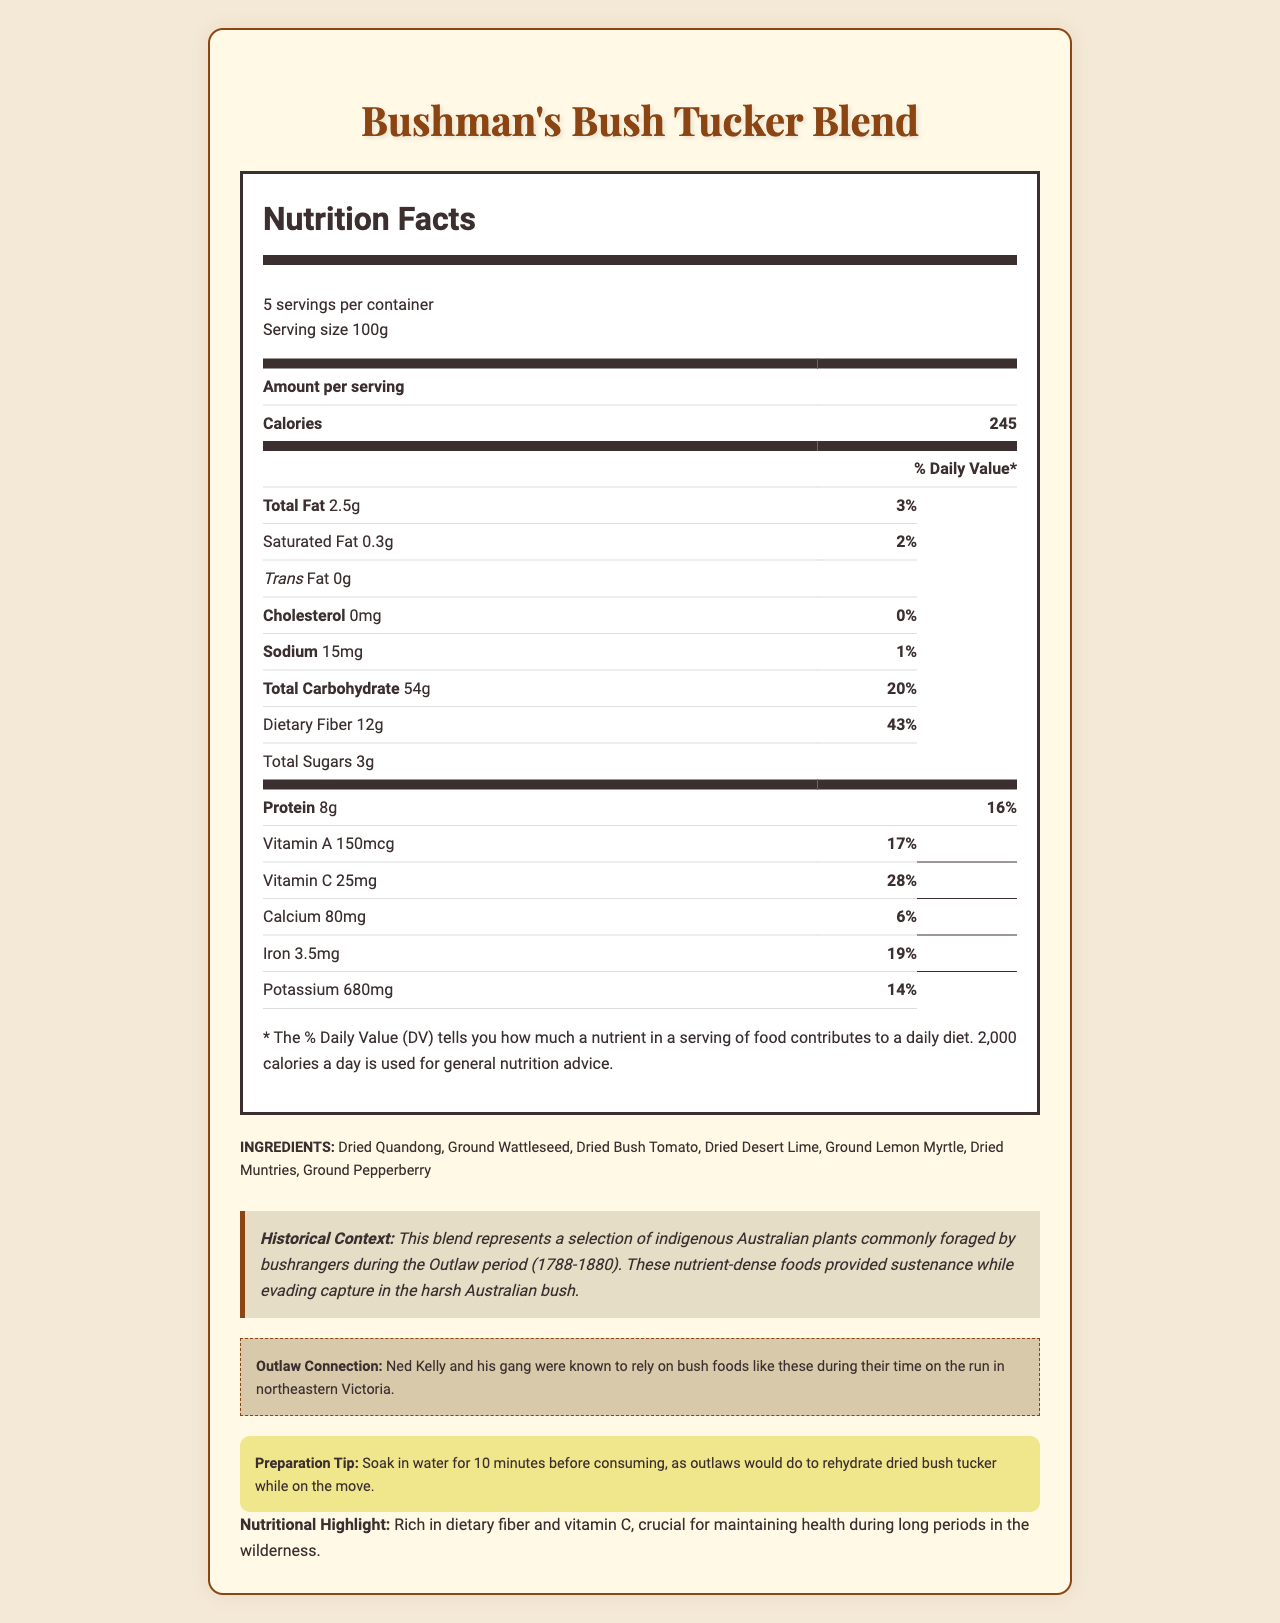What is the serving size of Bushman's Bush Tucker Blend? The serving size is listed at the beginning of the nutrition facts section as "Serving size 100g".
Answer: 100g How many servings are there per container? The servings per container are mentioned right after the serving size, listed as "5 servings per container".
Answer: 5 How many calories are in one serving? The number of calories per serving is shown in the calories section in bold, listed as 245.
Answer: 245 What is the amount of dietary fiber in one serving and its daily value percentage? The information is listed under the dietary fiber section, showing "Dietary Fiber 12g" and "43%" as the daily value.
Answer: 12g, 43% Which nutrient is present in the highest amount per serving in Bushman's Bush Tucker Blend? The highest nutrient amount listed in the nutrition facts is "Total Carbohydrate 54g".
Answer: Total Carbohydrate (54g) What ingredients are included in the Bushman's Bush Tucker Blend? The ingredients are listed in the ingredients section near the end of the document.
Answer: Dried Quandong, Ground Wattleseed, Dried Bush Tomato, Dried Desert Lime, Ground Lemon Myrtle, Dried Muntries, Ground Pepperberry What historical context is provided regarding the Bushman's Bush Tucker Blend? The historical context is given in a dedicated section that explains the significance of the blend during the Outlaw period.
Answer: This blend represents a selection of indigenous Australian plants commonly foraged by bushrangers during the Outlaw period (1788-1880). These nutrient-dense foods provided sustenance while evading capture in the harsh Australian bush. Which of the following nutrients is NOT found in considerable amounts in the blend? A. Iron B. Vitamin A C. Trans Fat D. Protein The trans fat amount is listed as 0g, indicating it is not found in considerable amounts in the blend.
Answer: C. Trans Fat How much protein does one serving of Bushman's Bush Tucker Blend contain, and what is the percentage of daily value? A. 6g, 12% B. 8g, 16% C. 10g, 20% D. 12g, 24% The protein content is listed as "Protein 8g" and the daily value percentage as "16%" in the nutrition facts table.
Answer: B. 8g, 16% Is there any cholesterol in the Bushman's Bush Tucker Blend? The cholesterol content is listed as 0mg, indicating no cholesterol is present in the blend.
Answer: No Can you describe the nutritional highlight of Bushman's Bush Tucker Blend? The nutritional highlight is mentioned at the end of the document, emphasizing the high dietary fiber and vitamin C content.
Answer: The blend is rich in dietary fiber and vitamin C, crucial for maintaining health during long periods in the wilderness. Who is mentioned as relying on similar bush foods during their time on the run? The document mentions Ned Kelly and his gang in the outlaw connection section, stating they relied on similar bush foods.
Answer: Ned Kelly and his gang What is the preparation tip for consuming Bushman's Bush Tucker Blend? The preparation tip is provided in a separate section, advising that the blend should be soaked in water for 10 minutes before consuming.
Answer: Soak in water for 10 minutes before consuming. Which document element provides information regarding potential allergens in the Bushman's Bush Tucker Blend? The potential allergen information is stated under the allergen info section.
Answer: Allergen info How many grams of total sugars are contained in one serving of Bushman's Bush Tucker Blend? The total sugars are listed under the carbohydrate section, showing "Total Sugars 3g".
Answer: 3g Could you mention the main idea or summarize the entire document? The document aims to inform the reader about the nutritional values, ingredients, and historical significance of the Bushman's Bush Tucker Blend, highlighting its importance during the Outlaw period.
Answer: The document provides detailed nutritional information, historical context, ingredients, preparation tips, and relevant allergy information for an indigenous Australian plant blend known as Bushman's Bush Tucker Blend. This blend was historically used by outlaws such as Ned Kelly and his gang for sustenance while evading capture. What are the exact quantities of potassium and vitamin A found in the blend? The exact quantities of potassium and vitamin A are given in the nutrition facts table in the respective sections.
Answer: Potassium: 680mg, Vitamin A: 150mcg Is the daily value percentage for calcium higher than for iron? The daily value percentage for calcium is 6%, which is lower than the 19% daily value for iron as listed in the nutrition facts.
Answer: No How can the historical context provided help in understanding the dietary needs of outlaws during the Outlaw period? The historical context mentions the use of the blend by outlaws but does not provide in-depth details on how it meets their specific dietary needs.
Answer: Not enough information What is the total fat content and its daily value percentage in Bushman's Bush Tucker Blend? The total fat content is listed as "Total Fat 2.5g" and the daily value is "3%" in the nutrition facts table.
Answer: 2.5g, 3% 